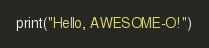Convert code to text. <code><loc_0><loc_0><loc_500><loc_500><_Python_>print("Hello, AWESOME-O!")
</code> 